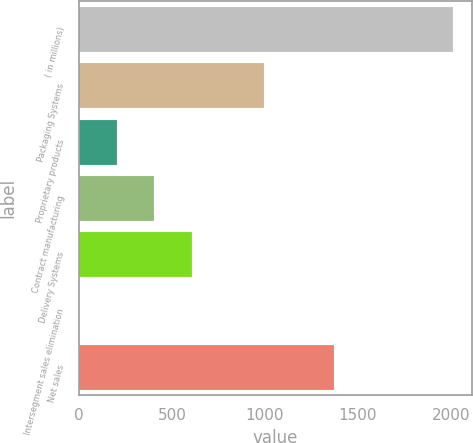Convert chart. <chart><loc_0><loc_0><loc_500><loc_500><bar_chart><fcel>( in millions)<fcel>Packaging Systems<fcel>Proprietary products<fcel>Contract manufacturing<fcel>Delivery Systems<fcel>Intersegment sales elimination<fcel>Net sales<nl><fcel>2013<fcel>996<fcel>202.83<fcel>403.96<fcel>605.09<fcel>1.7<fcel>1368.4<nl></chart> 